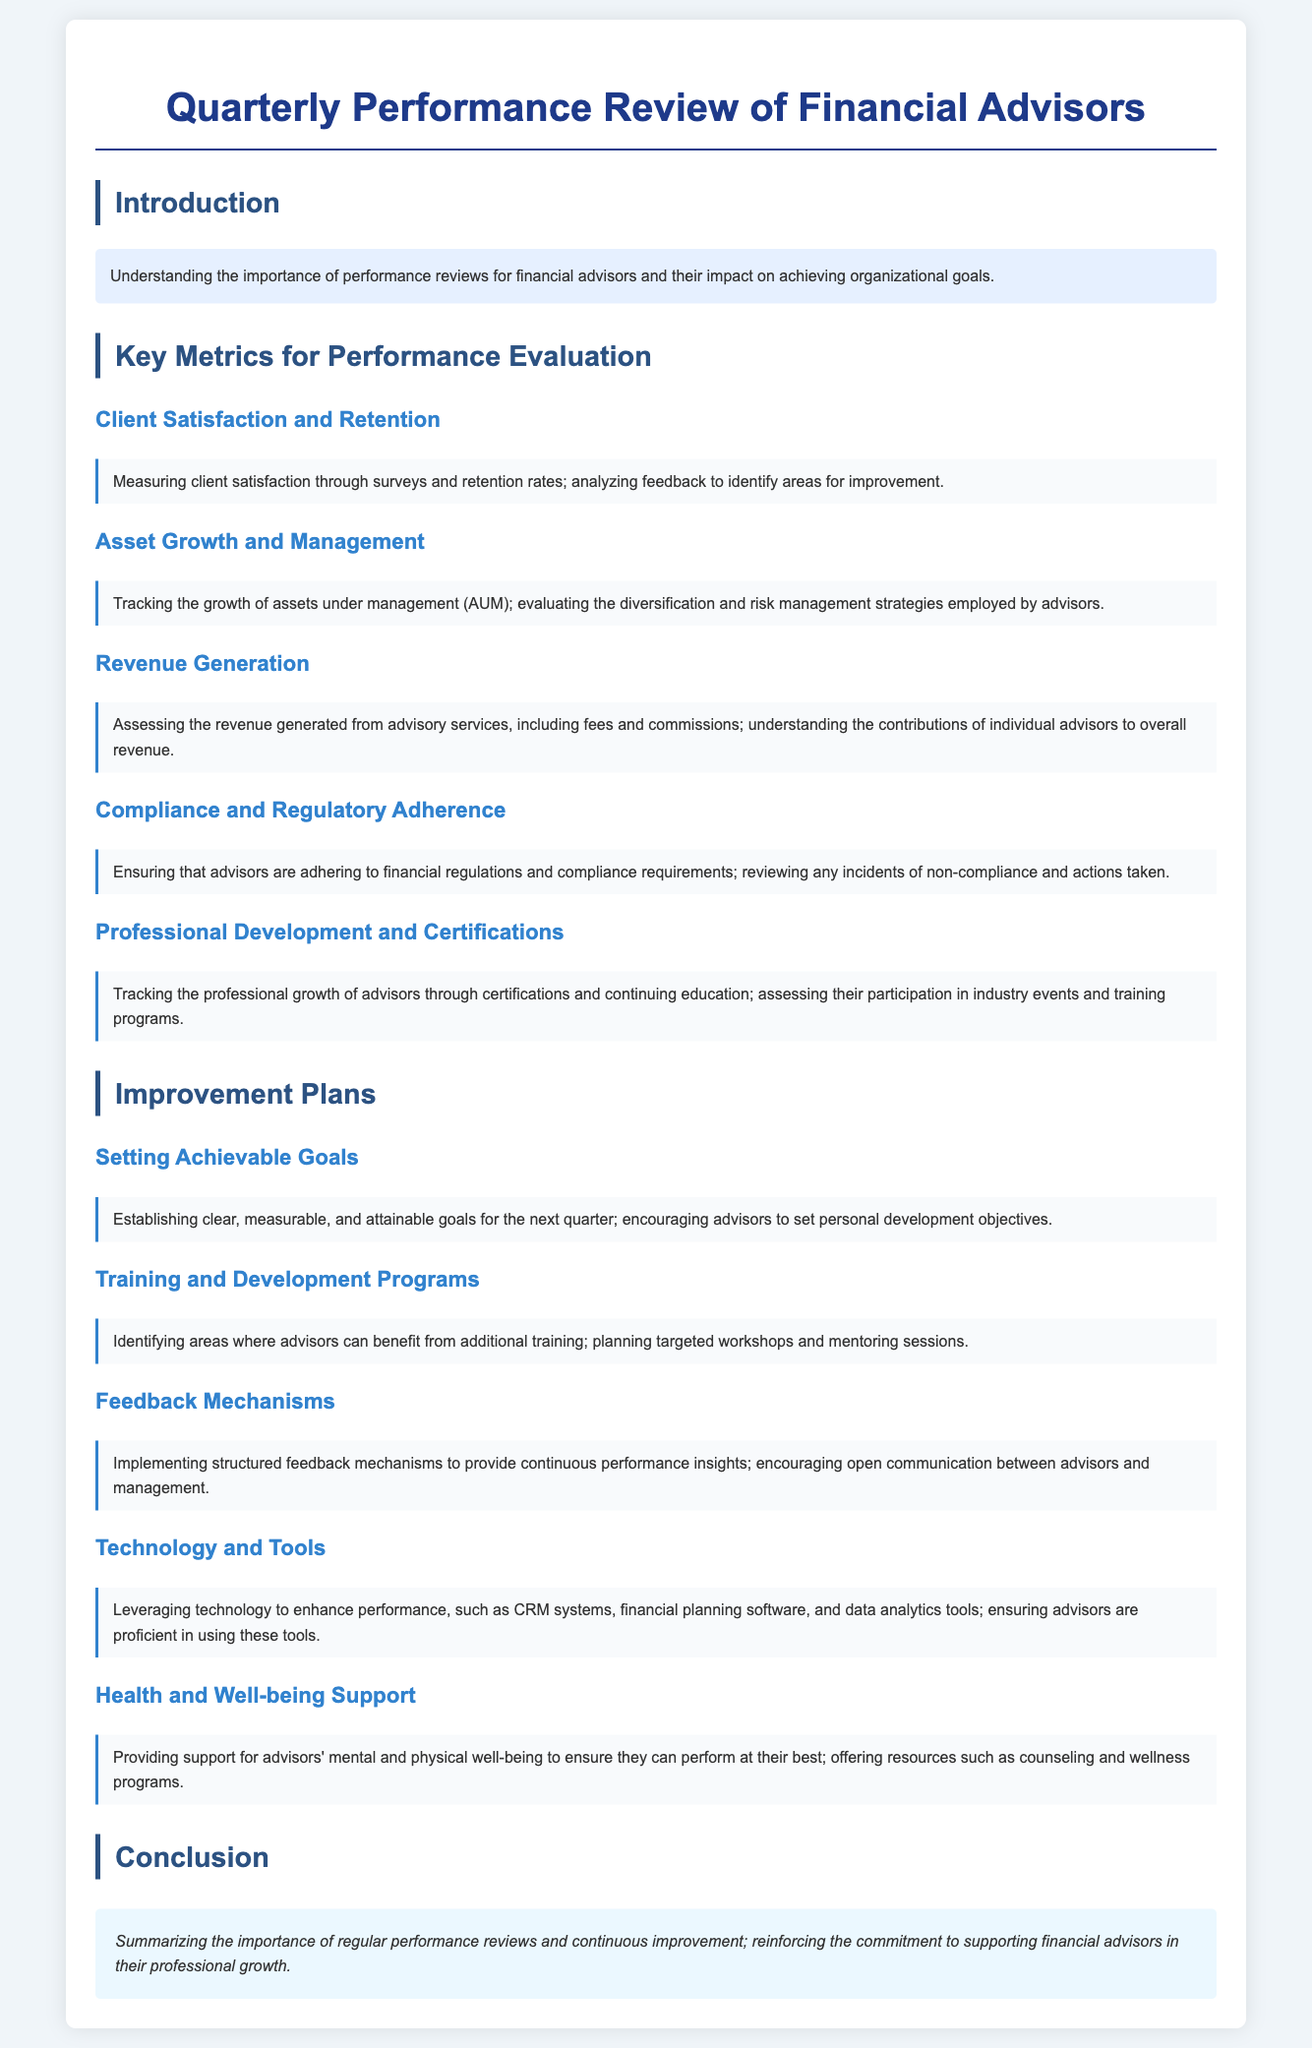What is the title of the document? The title of the document is given in the heading at the top of the rendered output.
Answer: Quarterly Performance Review of Financial Advisors What does the introduction emphasize? The introduction focuses on the significance of performance reviews for financial advisors and their organizational impact.
Answer: Importance of performance reviews Name one key metric for performance evaluation. The document lists several key metrics, and one example can be taken directly from the section titles.
Answer: Client Satisfaction and Retention What is being tracked under Asset Growth and Management? This section outlines the focus on the growth of assets under management and associated strategies.
Answer: Growth of assets under management What should improvement plans include according to the document? The document specifies several aspects that improvement plans should cover, and one example is mentioned.
Answer: Achievable goals What is one feature of the feedback mechanisms mentioned? The subsection highlights a specific characteristic of the feedback mechanisms in terms of structure and intent.
Answer: Continuous performance insights What type of support is recommended for advisors? The document suggests a type of support aimed at enhancing the advisor's capacity to perform.
Answer: Health and well-being support What is the conclusion's main focus? The conclusion summarizes key insights from earlier sections and reaffirms a commitment to certain processes.
Answer: Importance of regular performance reviews 